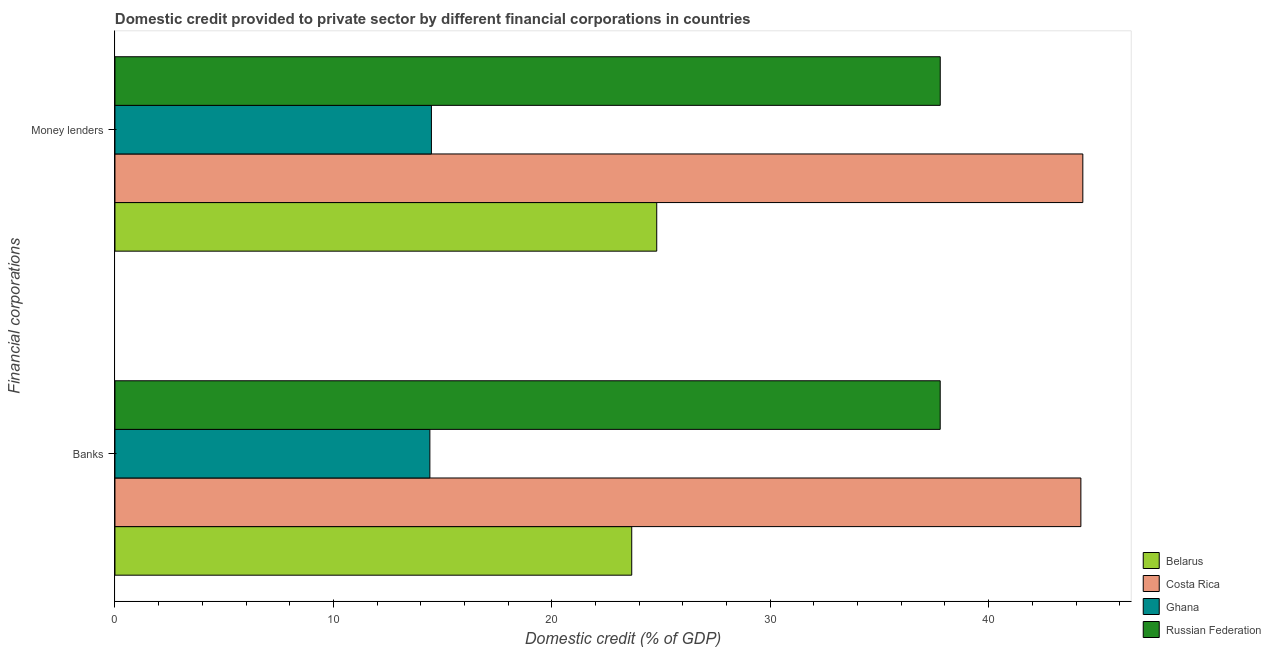Are the number of bars on each tick of the Y-axis equal?
Provide a succinct answer. Yes. How many bars are there on the 2nd tick from the top?
Keep it short and to the point. 4. What is the label of the 2nd group of bars from the top?
Make the answer very short. Banks. What is the domestic credit provided by money lenders in Russian Federation?
Offer a very short reply. 37.78. Across all countries, what is the maximum domestic credit provided by banks?
Offer a terse response. 44.22. Across all countries, what is the minimum domestic credit provided by banks?
Provide a short and direct response. 14.42. In which country was the domestic credit provided by banks minimum?
Your answer should be very brief. Ghana. What is the total domestic credit provided by banks in the graph?
Ensure brevity in your answer.  120.08. What is the difference between the domestic credit provided by banks in Ghana and that in Russian Federation?
Provide a short and direct response. -23.36. What is the difference between the domestic credit provided by banks in Ghana and the domestic credit provided by money lenders in Costa Rica?
Offer a terse response. -29.89. What is the average domestic credit provided by banks per country?
Keep it short and to the point. 30.02. What is the difference between the domestic credit provided by money lenders and domestic credit provided by banks in Belarus?
Provide a short and direct response. 1.14. In how many countries, is the domestic credit provided by money lenders greater than 16 %?
Your answer should be compact. 3. What is the ratio of the domestic credit provided by money lenders in Ghana to that in Costa Rica?
Your answer should be compact. 0.33. In how many countries, is the domestic credit provided by money lenders greater than the average domestic credit provided by money lenders taken over all countries?
Provide a succinct answer. 2. Are the values on the major ticks of X-axis written in scientific E-notation?
Provide a short and direct response. No. Where does the legend appear in the graph?
Ensure brevity in your answer.  Bottom right. How are the legend labels stacked?
Your response must be concise. Vertical. What is the title of the graph?
Your response must be concise. Domestic credit provided to private sector by different financial corporations in countries. What is the label or title of the X-axis?
Offer a very short reply. Domestic credit (% of GDP). What is the label or title of the Y-axis?
Your answer should be very brief. Financial corporations. What is the Domestic credit (% of GDP) in Belarus in Banks?
Ensure brevity in your answer.  23.66. What is the Domestic credit (% of GDP) in Costa Rica in Banks?
Give a very brief answer. 44.22. What is the Domestic credit (% of GDP) of Ghana in Banks?
Ensure brevity in your answer.  14.42. What is the Domestic credit (% of GDP) in Russian Federation in Banks?
Your answer should be very brief. 37.78. What is the Domestic credit (% of GDP) of Belarus in Money lenders?
Give a very brief answer. 24.8. What is the Domestic credit (% of GDP) in Costa Rica in Money lenders?
Your answer should be compact. 44.31. What is the Domestic credit (% of GDP) of Ghana in Money lenders?
Make the answer very short. 14.49. What is the Domestic credit (% of GDP) in Russian Federation in Money lenders?
Provide a short and direct response. 37.78. Across all Financial corporations, what is the maximum Domestic credit (% of GDP) in Belarus?
Make the answer very short. 24.8. Across all Financial corporations, what is the maximum Domestic credit (% of GDP) of Costa Rica?
Make the answer very short. 44.31. Across all Financial corporations, what is the maximum Domestic credit (% of GDP) of Ghana?
Offer a terse response. 14.49. Across all Financial corporations, what is the maximum Domestic credit (% of GDP) of Russian Federation?
Give a very brief answer. 37.78. Across all Financial corporations, what is the minimum Domestic credit (% of GDP) of Belarus?
Keep it short and to the point. 23.66. Across all Financial corporations, what is the minimum Domestic credit (% of GDP) in Costa Rica?
Ensure brevity in your answer.  44.22. Across all Financial corporations, what is the minimum Domestic credit (% of GDP) of Ghana?
Offer a very short reply. 14.42. Across all Financial corporations, what is the minimum Domestic credit (% of GDP) in Russian Federation?
Keep it short and to the point. 37.78. What is the total Domestic credit (% of GDP) in Belarus in the graph?
Your answer should be compact. 48.46. What is the total Domestic credit (% of GDP) in Costa Rica in the graph?
Offer a very short reply. 88.53. What is the total Domestic credit (% of GDP) in Ghana in the graph?
Ensure brevity in your answer.  28.91. What is the total Domestic credit (% of GDP) in Russian Federation in the graph?
Your answer should be compact. 75.57. What is the difference between the Domestic credit (% of GDP) of Belarus in Banks and that in Money lenders?
Ensure brevity in your answer.  -1.14. What is the difference between the Domestic credit (% of GDP) in Costa Rica in Banks and that in Money lenders?
Your answer should be compact. -0.09. What is the difference between the Domestic credit (% of GDP) in Ghana in Banks and that in Money lenders?
Offer a terse response. -0.07. What is the difference between the Domestic credit (% of GDP) of Russian Federation in Banks and that in Money lenders?
Offer a very short reply. -0. What is the difference between the Domestic credit (% of GDP) of Belarus in Banks and the Domestic credit (% of GDP) of Costa Rica in Money lenders?
Your answer should be compact. -20.65. What is the difference between the Domestic credit (% of GDP) of Belarus in Banks and the Domestic credit (% of GDP) of Ghana in Money lenders?
Keep it short and to the point. 9.17. What is the difference between the Domestic credit (% of GDP) in Belarus in Banks and the Domestic credit (% of GDP) in Russian Federation in Money lenders?
Ensure brevity in your answer.  -14.12. What is the difference between the Domestic credit (% of GDP) in Costa Rica in Banks and the Domestic credit (% of GDP) in Ghana in Money lenders?
Offer a terse response. 29.73. What is the difference between the Domestic credit (% of GDP) in Costa Rica in Banks and the Domestic credit (% of GDP) in Russian Federation in Money lenders?
Your response must be concise. 6.44. What is the difference between the Domestic credit (% of GDP) of Ghana in Banks and the Domestic credit (% of GDP) of Russian Federation in Money lenders?
Provide a succinct answer. -23.37. What is the average Domestic credit (% of GDP) of Belarus per Financial corporations?
Your answer should be very brief. 24.23. What is the average Domestic credit (% of GDP) of Costa Rica per Financial corporations?
Your response must be concise. 44.27. What is the average Domestic credit (% of GDP) in Ghana per Financial corporations?
Make the answer very short. 14.45. What is the average Domestic credit (% of GDP) in Russian Federation per Financial corporations?
Offer a very short reply. 37.78. What is the difference between the Domestic credit (% of GDP) of Belarus and Domestic credit (% of GDP) of Costa Rica in Banks?
Give a very brief answer. -20.56. What is the difference between the Domestic credit (% of GDP) in Belarus and Domestic credit (% of GDP) in Ghana in Banks?
Provide a short and direct response. 9.24. What is the difference between the Domestic credit (% of GDP) of Belarus and Domestic credit (% of GDP) of Russian Federation in Banks?
Your answer should be very brief. -14.12. What is the difference between the Domestic credit (% of GDP) in Costa Rica and Domestic credit (% of GDP) in Ghana in Banks?
Make the answer very short. 29.8. What is the difference between the Domestic credit (% of GDP) in Costa Rica and Domestic credit (% of GDP) in Russian Federation in Banks?
Provide a succinct answer. 6.44. What is the difference between the Domestic credit (% of GDP) in Ghana and Domestic credit (% of GDP) in Russian Federation in Banks?
Your answer should be very brief. -23.36. What is the difference between the Domestic credit (% of GDP) of Belarus and Domestic credit (% of GDP) of Costa Rica in Money lenders?
Offer a very short reply. -19.51. What is the difference between the Domestic credit (% of GDP) in Belarus and Domestic credit (% of GDP) in Ghana in Money lenders?
Provide a short and direct response. 10.32. What is the difference between the Domestic credit (% of GDP) of Belarus and Domestic credit (% of GDP) of Russian Federation in Money lenders?
Offer a very short reply. -12.98. What is the difference between the Domestic credit (% of GDP) in Costa Rica and Domestic credit (% of GDP) in Ghana in Money lenders?
Keep it short and to the point. 29.82. What is the difference between the Domestic credit (% of GDP) in Costa Rica and Domestic credit (% of GDP) in Russian Federation in Money lenders?
Offer a terse response. 6.53. What is the difference between the Domestic credit (% of GDP) of Ghana and Domestic credit (% of GDP) of Russian Federation in Money lenders?
Provide a succinct answer. -23.3. What is the ratio of the Domestic credit (% of GDP) of Belarus in Banks to that in Money lenders?
Your response must be concise. 0.95. What is the ratio of the Domestic credit (% of GDP) of Costa Rica in Banks to that in Money lenders?
Your answer should be very brief. 1. What is the ratio of the Domestic credit (% of GDP) in Russian Federation in Banks to that in Money lenders?
Offer a very short reply. 1. What is the difference between the highest and the second highest Domestic credit (% of GDP) of Belarus?
Offer a very short reply. 1.14. What is the difference between the highest and the second highest Domestic credit (% of GDP) of Costa Rica?
Offer a very short reply. 0.09. What is the difference between the highest and the second highest Domestic credit (% of GDP) in Ghana?
Offer a very short reply. 0.07. What is the difference between the highest and the second highest Domestic credit (% of GDP) of Russian Federation?
Provide a succinct answer. 0. What is the difference between the highest and the lowest Domestic credit (% of GDP) of Belarus?
Your response must be concise. 1.14. What is the difference between the highest and the lowest Domestic credit (% of GDP) in Costa Rica?
Give a very brief answer. 0.09. What is the difference between the highest and the lowest Domestic credit (% of GDP) in Ghana?
Give a very brief answer. 0.07. What is the difference between the highest and the lowest Domestic credit (% of GDP) of Russian Federation?
Provide a short and direct response. 0. 